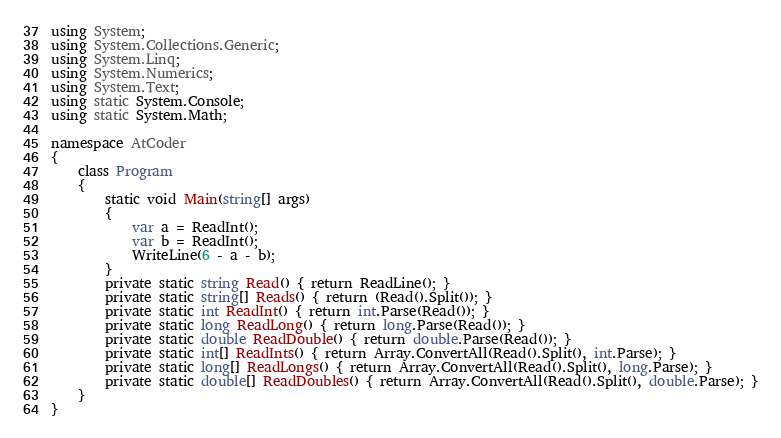Convert code to text. <code><loc_0><loc_0><loc_500><loc_500><_C#_>using System;
using System.Collections.Generic;
using System.Linq;
using System.Numerics;
using System.Text;
using static System.Console;
using static System.Math;

namespace AtCoder
{
    class Program
    {
        static void Main(string[] args)
        {
            var a = ReadInt();
            var b = ReadInt();
            WriteLine(6 - a - b);
        }
        private static string Read() { return ReadLine(); }
        private static string[] Reads() { return (Read().Split()); }
        private static int ReadInt() { return int.Parse(Read()); }
        private static long ReadLong() { return long.Parse(Read()); }
        private static double ReadDouble() { return double.Parse(Read()); }
        private static int[] ReadInts() { return Array.ConvertAll(Read().Split(), int.Parse); }
        private static long[] ReadLongs() { return Array.ConvertAll(Read().Split(), long.Parse); }
        private static double[] ReadDoubles() { return Array.ConvertAll(Read().Split(), double.Parse); }
    }
}
</code> 